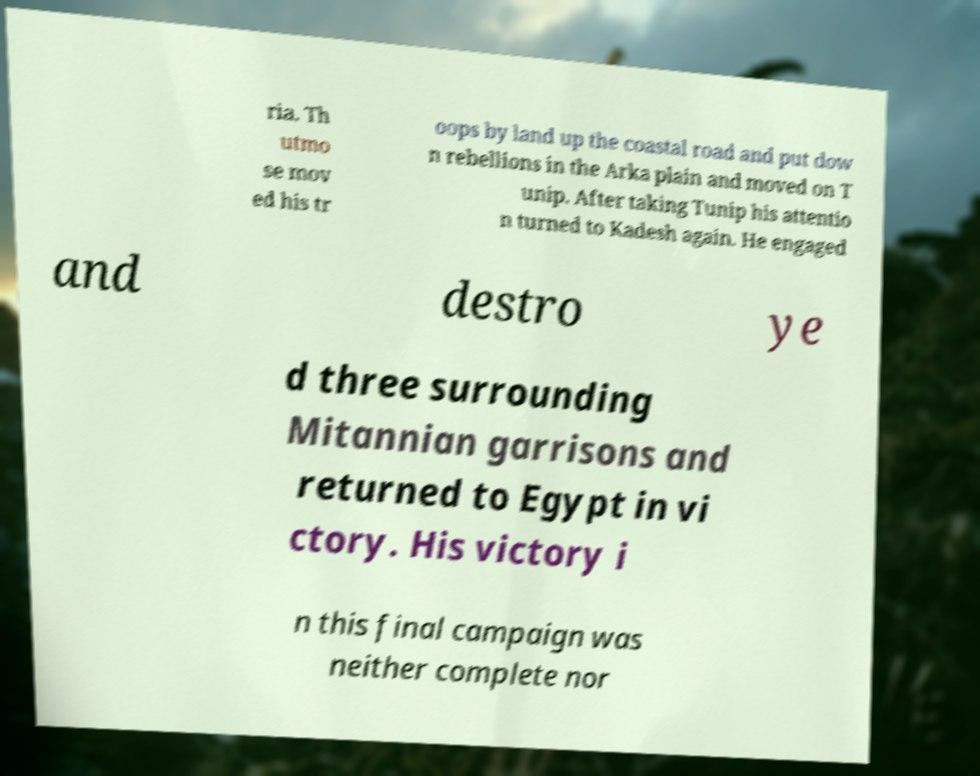Please identify and transcribe the text found in this image. ria. Th utmo se mov ed his tr oops by land up the coastal road and put dow n rebellions in the Arka plain and moved on T unip. After taking Tunip his attentio n turned to Kadesh again. He engaged and destro ye d three surrounding Mitannian garrisons and returned to Egypt in vi ctory. His victory i n this final campaign was neither complete nor 